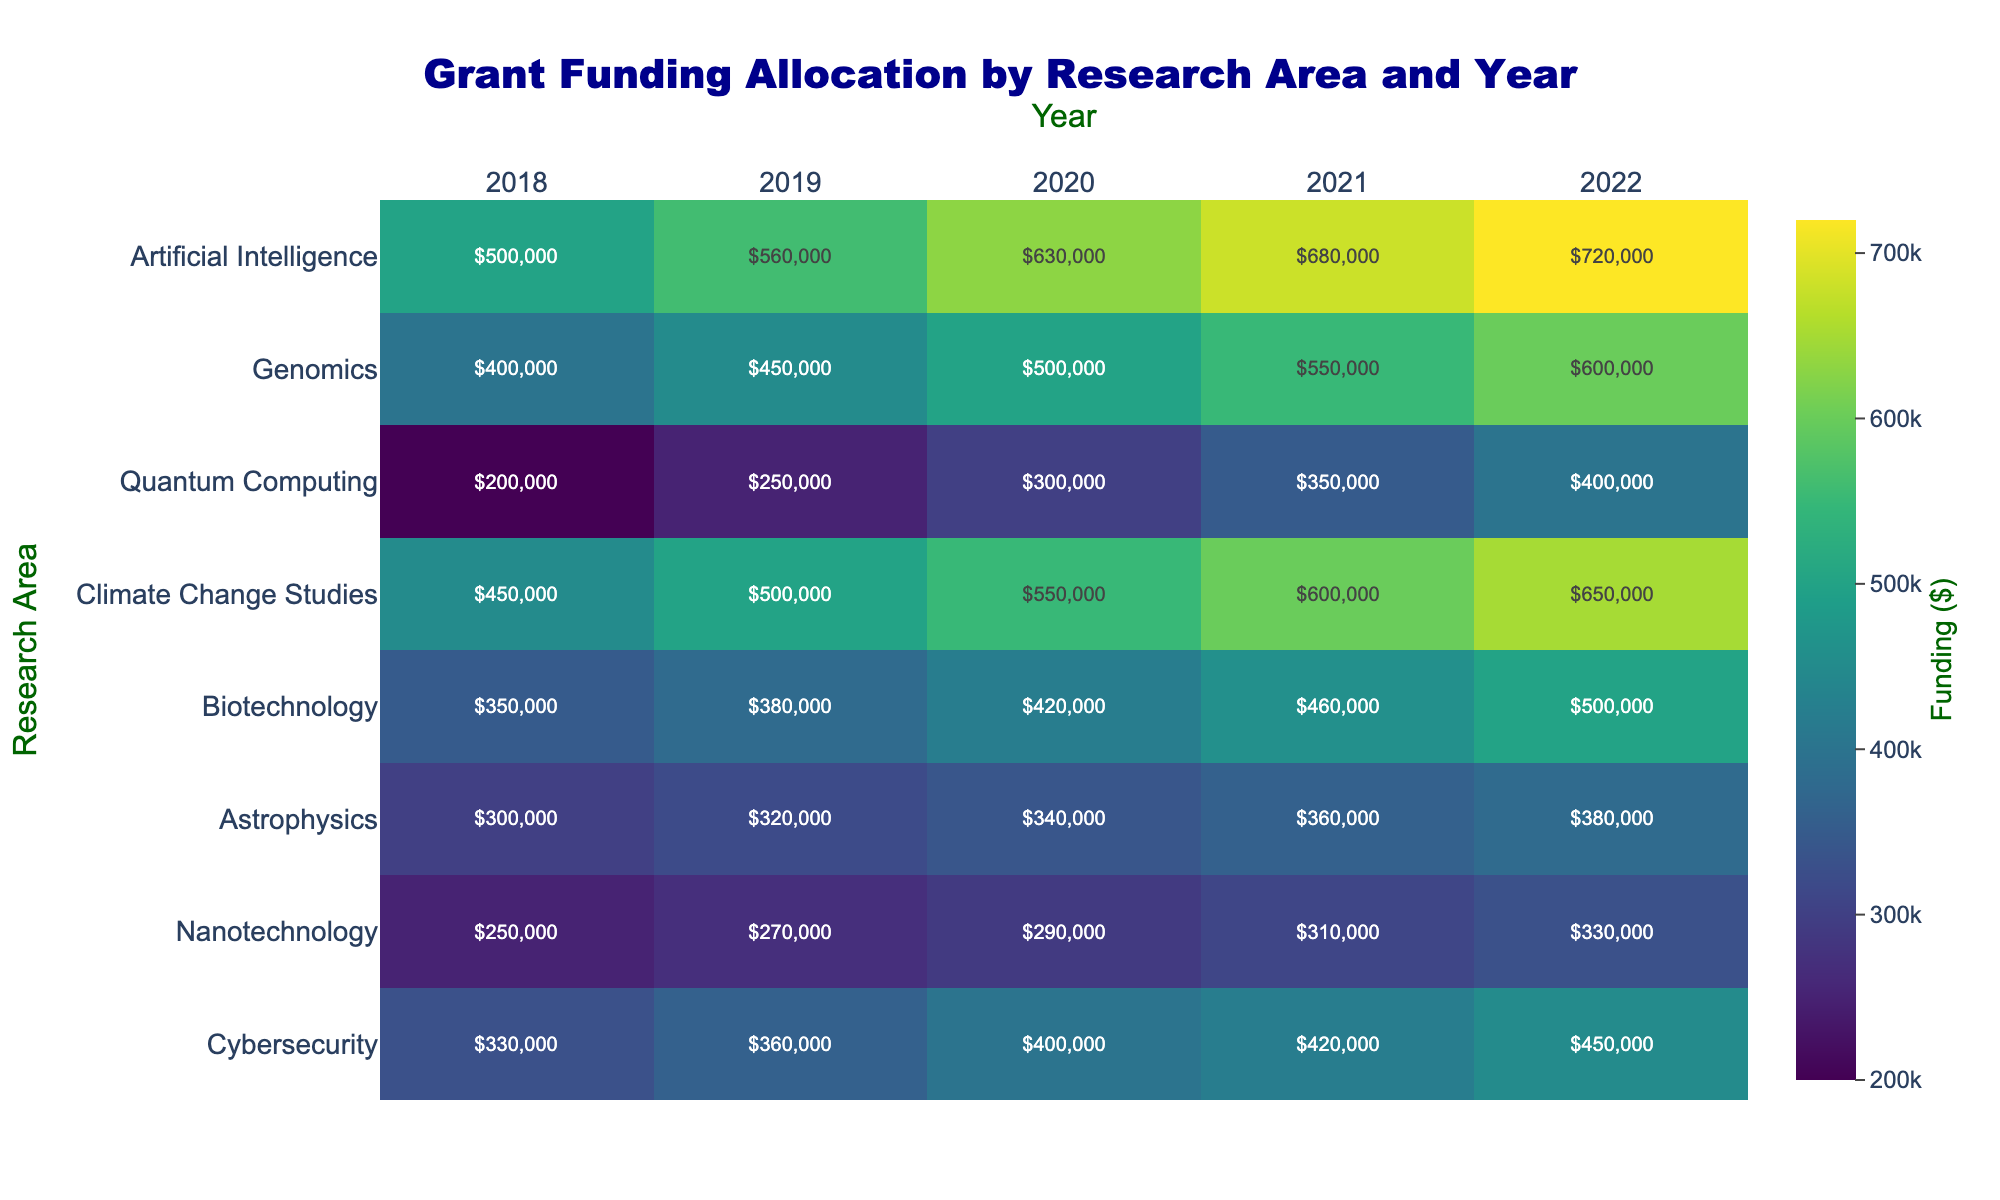What is the funding amount for Astrophysics in 2022? To find the funding amount for Astrophysics in 2022, locate the corresponding cell in the heatmap by identifying the row for Astrophysics and the column for 2022.
Answer: $380,000 Which research area received the highest funding in 2019? Compare the funding amounts for each research area in 2019 and identify the highest value.
Answer: Artificial Intelligence How has the funding for Quantum Computing changed over the years? Observe the trend in the Quantum Computing row across the years from 2018 to 2022 to see how the values increase annually.
Answer: Increased What is the total funding for Biotechnology over all the years? Add up the funding amounts for Biotechnology from 2018 to 2022: 350000 + 380000 + 420000 + 460000 + 500000.
Answer: $2,110,000 Which research area had the smallest funding increase from 2018 to 2022? Calculate the increase for each research area by subtracting the 2018 funding from the 2022 funding and compare the differences.
Answer: Nanotechnology Are there any years where Nanotechnology received less than $300,000 in funding? Check the funding amounts for Nanotechnology across all years to see if any values are below $300,000.
Answer: Yes, in 2018 and 2019 How does the funding for Climate Change Studies in 2021 compare to Genomics in the same year? Locate the funding amounts for both research areas in 2021 and compare them to determine which is higher.
Answer: Climate Change Studies What was the average funding amount for Cybersecurity over the observed years? Calculate the mean by summing the funding amounts for Cybersecurity from 2018 to 2022 and then dividing by 5: (330000 + 360000 + 400000 + 420000 + 450000) / 5.
Answer: $392,000 Which research area saw the most significant funding growth between 2018 and 2022? Determine the growth by subtracting the 2018 funding amount from the 2022 amount for each research area and identifying the largest difference.
Answer: Artificial Intelligence 